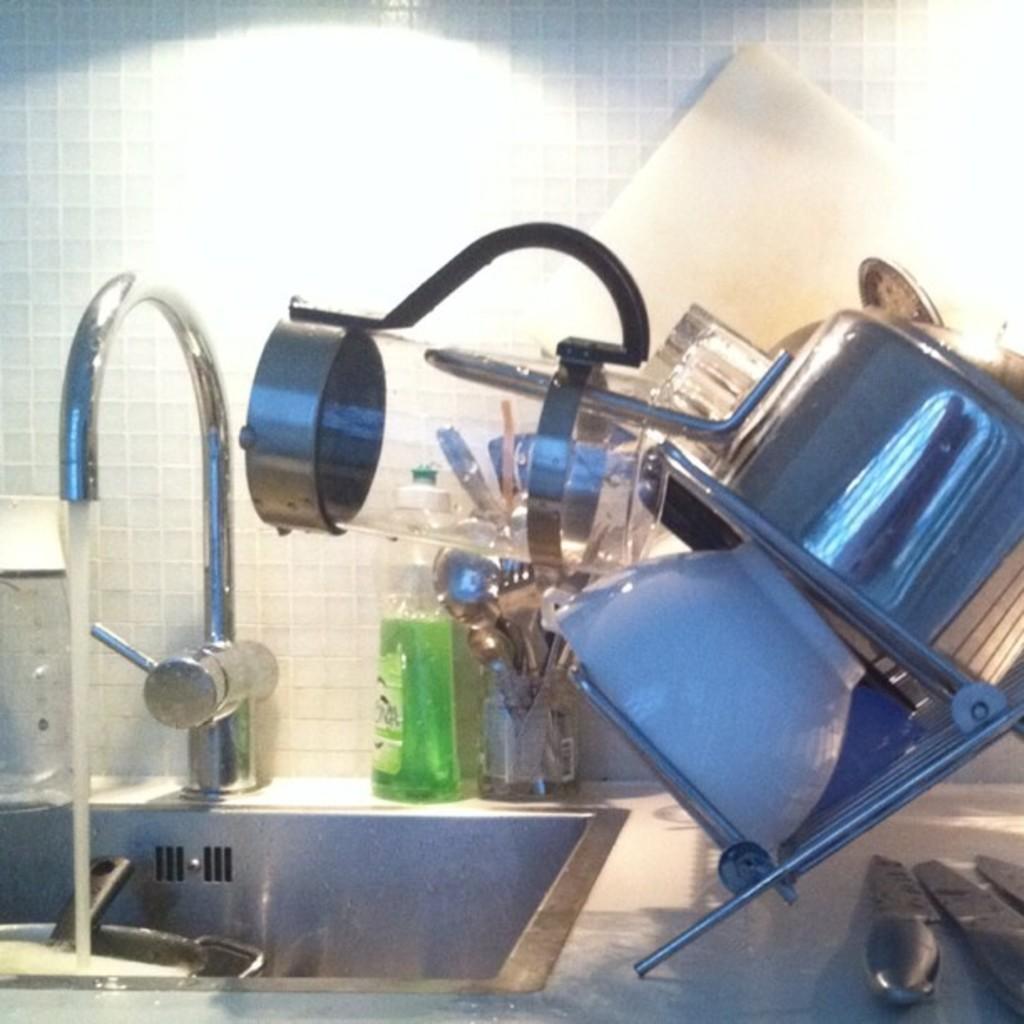Can you describe this image briefly? In this image I can see a kitchen cabinet, sink, tap, kitchen tools, vessels, light and a wall. This image is taken may be in a room. 